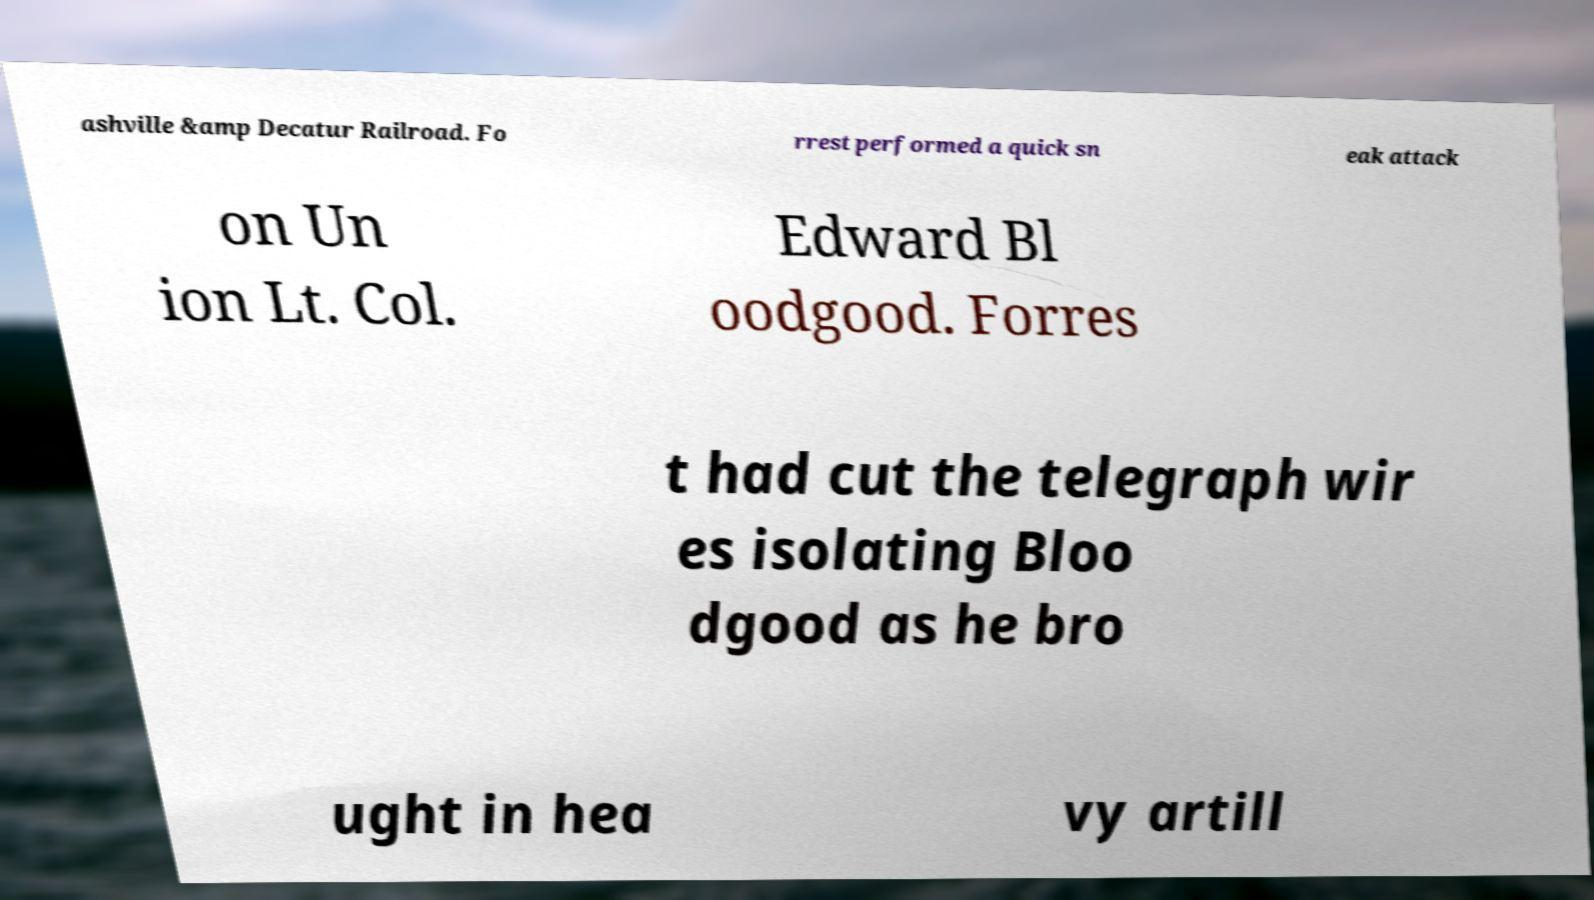Could you assist in decoding the text presented in this image and type it out clearly? ashville &amp Decatur Railroad. Fo rrest performed a quick sn eak attack on Un ion Lt. Col. Edward Bl oodgood. Forres t had cut the telegraph wir es isolating Bloo dgood as he bro ught in hea vy artill 